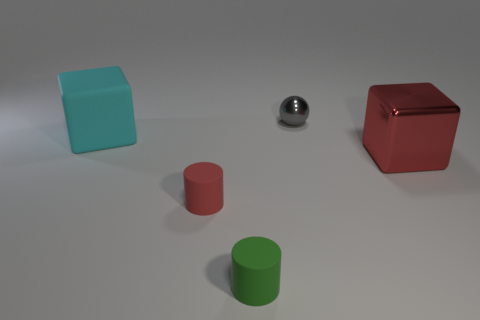Is there a cylinder made of the same material as the tiny gray object?
Provide a short and direct response. No. What material is the red thing that is in front of the block to the right of the small gray shiny sphere made of?
Provide a short and direct response. Rubber. How many large cubes are the same color as the small metal sphere?
Your answer should be very brief. 0. There is another cylinder that is made of the same material as the green cylinder; what size is it?
Make the answer very short. Small. What is the shape of the red object left of the green cylinder?
Give a very brief answer. Cylinder. There is a matte object that is the same shape as the large metallic thing; what size is it?
Provide a succinct answer. Large. How many big red cubes are in front of the cylinder that is to the right of the matte cylinder that is behind the tiny green matte object?
Your response must be concise. 0. Are there an equal number of spheres that are in front of the big cyan cube and tiny gray objects?
Keep it short and to the point. No. What number of cylinders are tiny matte objects or gray metallic objects?
Offer a very short reply. 2. Are there the same number of red matte objects that are in front of the gray sphere and metallic things that are in front of the cyan cube?
Give a very brief answer. Yes. 